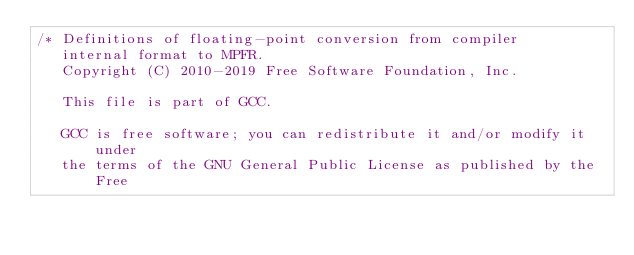<code> <loc_0><loc_0><loc_500><loc_500><_C_>/* Definitions of floating-point conversion from compiler
   internal format to MPFR.
   Copyright (C) 2010-2019 Free Software Foundation, Inc.

   This file is part of GCC.

   GCC is free software; you can redistribute it and/or modify it under
   the terms of the GNU General Public License as published by the Free</code> 